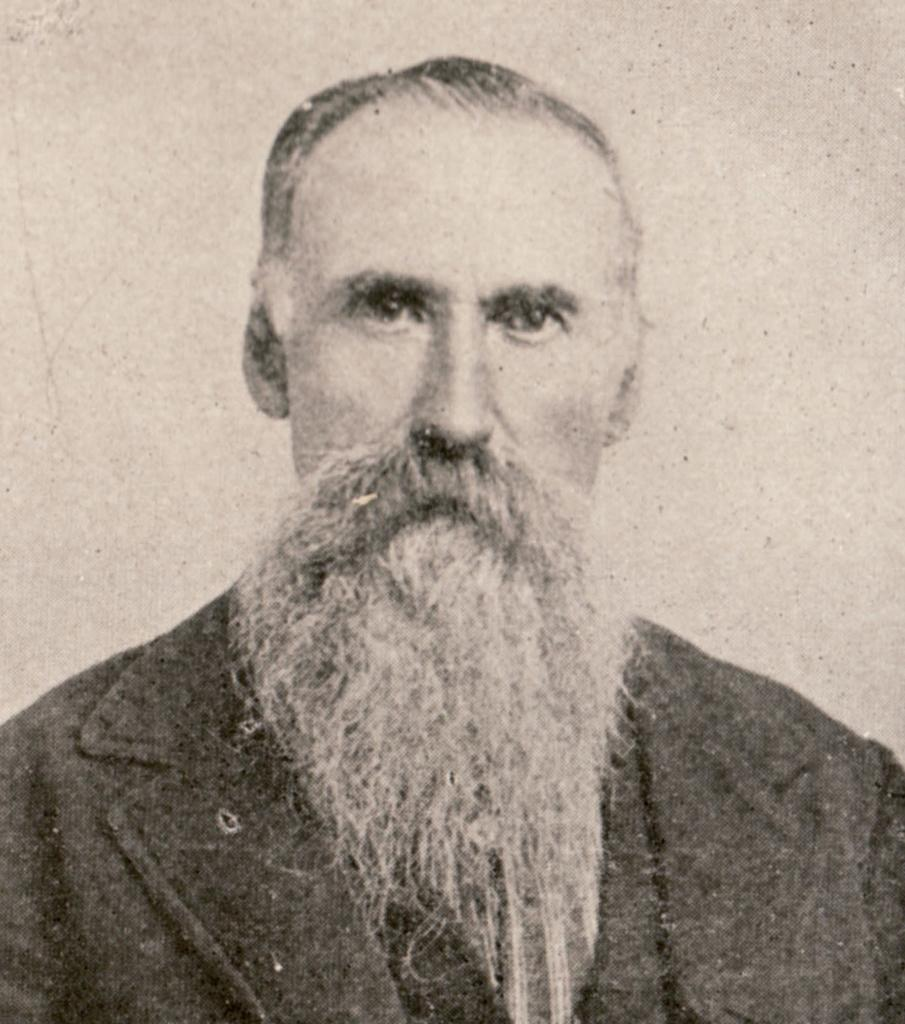What is the color scheme of the image? The image is black and white. Can you describe the main subject in the image? There is a person in the image. What is a noticeable feature of the person? The person has a beard. How many doors can be seen in the image? There are no doors visible in the image, as it is a black and white image featuring a person with a beard. 